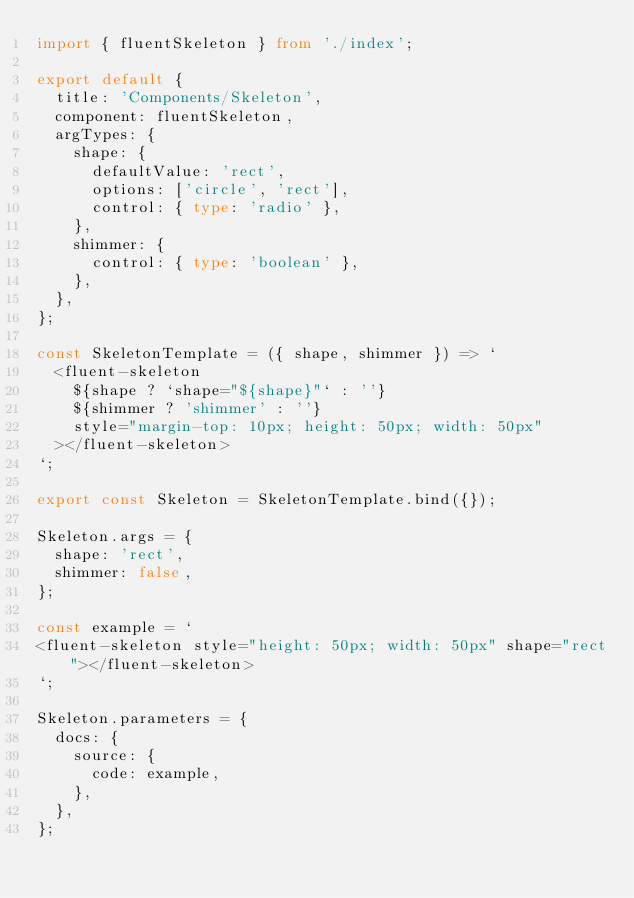Convert code to text. <code><loc_0><loc_0><loc_500><loc_500><_TypeScript_>import { fluentSkeleton } from './index';

export default {
  title: 'Components/Skeleton',
  component: fluentSkeleton,
  argTypes: {
    shape: {
      defaultValue: 'rect',
      options: ['circle', 'rect'],
      control: { type: 'radio' },
    },
    shimmer: {
      control: { type: 'boolean' },
    },
  },
};

const SkeletonTemplate = ({ shape, shimmer }) => `
  <fluent-skeleton 
    ${shape ? `shape="${shape}"` : ''}
    ${shimmer ? 'shimmer' : ''} 
    style="margin-top: 10px; height: 50px; width: 50px"
  ></fluent-skeleton>
`;

export const Skeleton = SkeletonTemplate.bind({});

Skeleton.args = {
  shape: 'rect',
  shimmer: false,
};

const example = `
<fluent-skeleton style="height: 50px; width: 50px" shape="rect"></fluent-skeleton>
`;

Skeleton.parameters = {
  docs: {
    source: {
      code: example,
    },
  },
};
</code> 